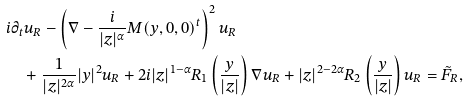Convert formula to latex. <formula><loc_0><loc_0><loc_500><loc_500>& i \partial _ { t } u _ { R } - \left ( \nabla - \frac { i } { | z | ^ { \alpha } } M ( y , 0 , 0 ) ^ { t } \right ) ^ { 2 } u _ { R } \\ & \quad + \frac { 1 } { | z | ^ { 2 \alpha } } | y | ^ { 2 } u _ { R } + 2 i | z | ^ { 1 - \alpha } R _ { 1 } \left ( \frac { y } { | z | } \right ) \nabla u _ { R } + | z | ^ { 2 - 2 \alpha } R _ { 2 } \left ( \frac { y } { | z | } \right ) u _ { R } = \tilde { F } _ { R } ,</formula> 